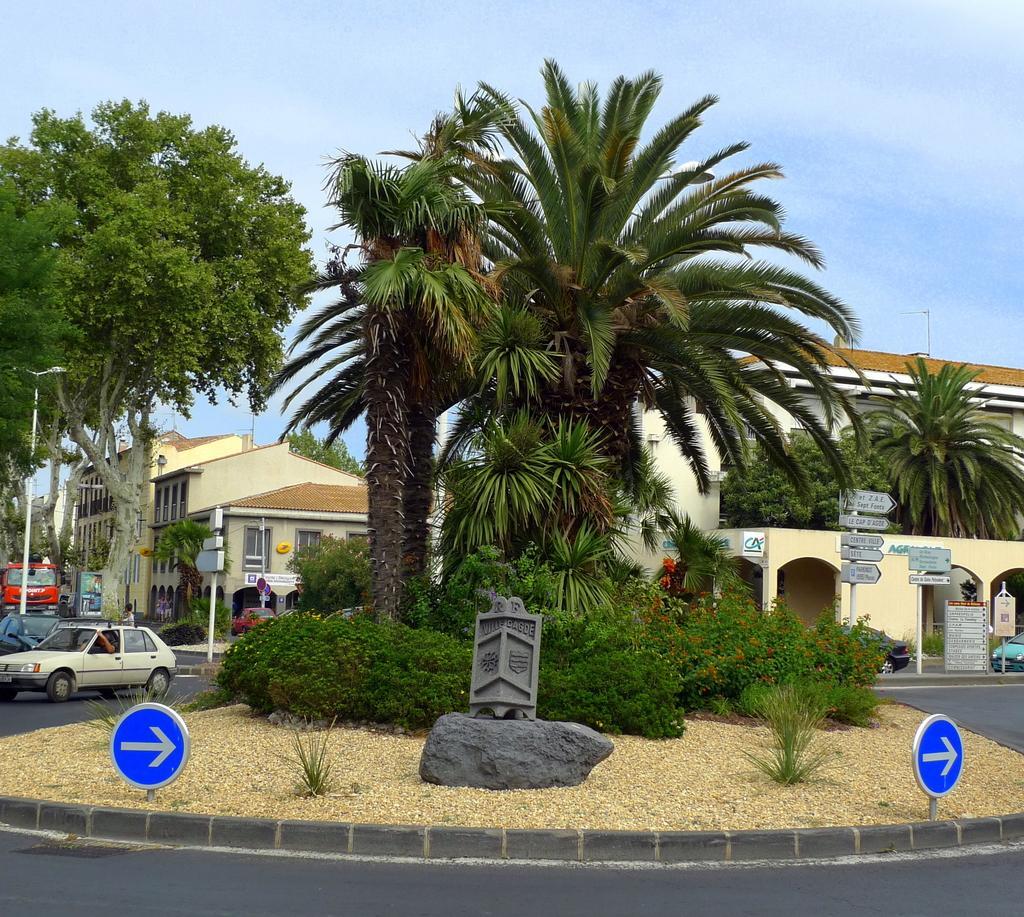In one or two sentences, can you explain what this image depicts? In the image there are many palm trees in the front with road on either side of it and a car on the left side, in the back there are buildings and above its sky. 